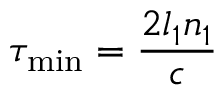<formula> <loc_0><loc_0><loc_500><loc_500>\tau _ { \min } = \frac { 2 l _ { 1 } n _ { 1 } } { c }</formula> 